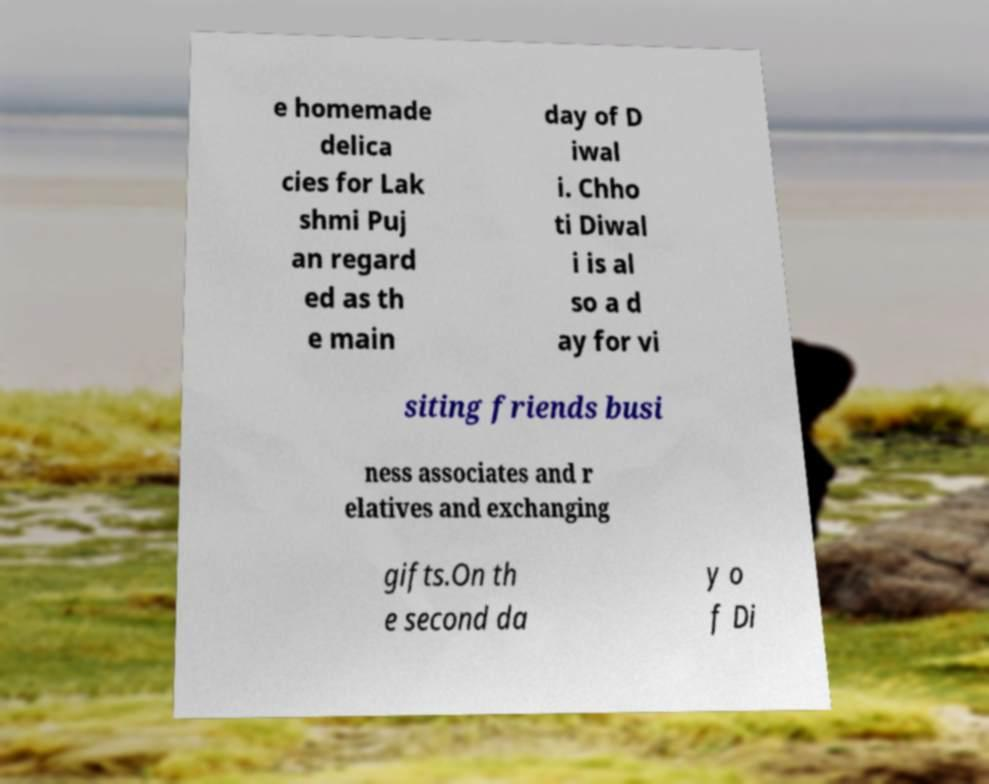What messages or text are displayed in this image? I need them in a readable, typed format. e homemade delica cies for Lak shmi Puj an regard ed as th e main day of D iwal i. Chho ti Diwal i is al so a d ay for vi siting friends busi ness associates and r elatives and exchanging gifts.On th e second da y o f Di 